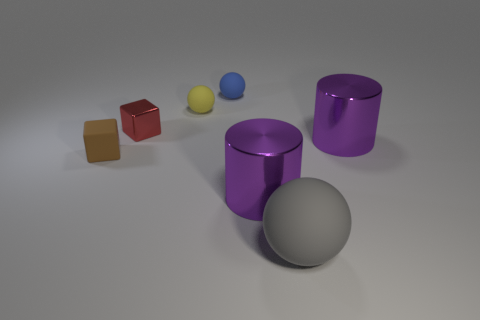How many other rubber blocks are the same color as the small matte cube?
Offer a very short reply. 0. There is a block that is the same material as the blue object; what size is it?
Ensure brevity in your answer.  Small. What is the size of the cube in front of the block behind the tiny matte thing that is in front of the tiny red cube?
Provide a short and direct response. Small. There is a cube in front of the small metallic thing; how big is it?
Ensure brevity in your answer.  Small. How many yellow objects are large things or metallic objects?
Make the answer very short. 0. Is there a purple thing that has the same size as the blue matte ball?
Provide a short and direct response. No. There is a blue ball that is the same size as the rubber block; what is it made of?
Offer a very short reply. Rubber. Is the size of the sphere behind the small yellow matte sphere the same as the purple thing that is to the right of the big gray matte object?
Give a very brief answer. No. How many things are either big red metal objects or things that are to the left of the yellow rubber object?
Make the answer very short. 2. Are there any tiny yellow objects that have the same shape as the gray matte thing?
Your answer should be compact. Yes. 